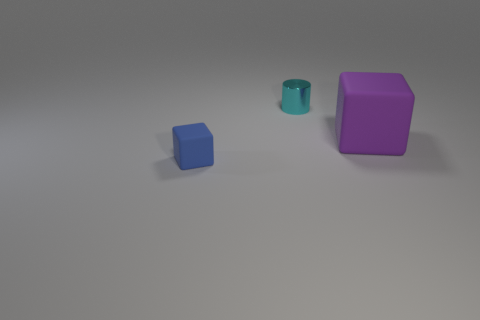Add 1 blue matte blocks. How many objects exist? 4 Subtract 1 cylinders. How many cylinders are left? 0 Subtract all blue cubes. How many cubes are left? 1 Subtract all cubes. How many objects are left? 1 Subtract all big matte things. Subtract all purple matte objects. How many objects are left? 1 Add 2 blue blocks. How many blue blocks are left? 3 Add 2 purple matte blocks. How many purple matte blocks exist? 3 Subtract 0 red balls. How many objects are left? 3 Subtract all yellow cubes. Subtract all purple cylinders. How many cubes are left? 2 Subtract all green blocks. How many red cylinders are left? 0 